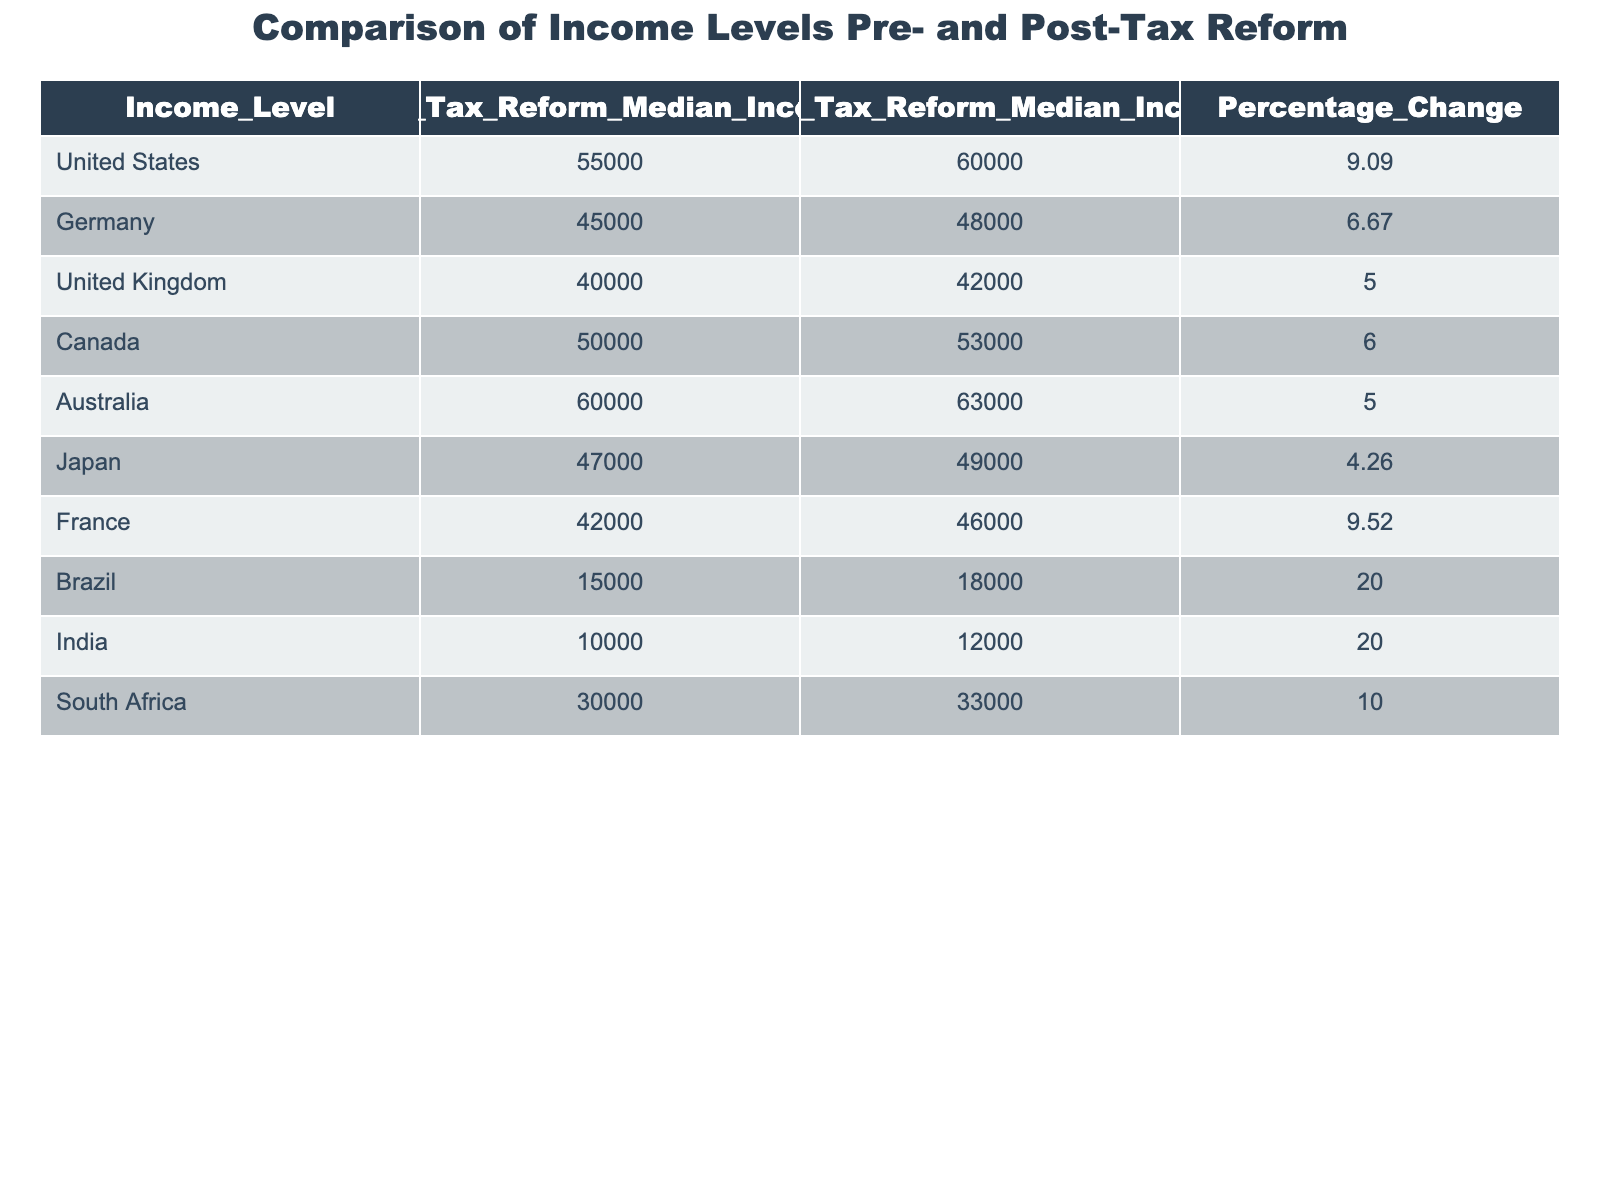What is the median income for Canada before the tax reform? The table shows that the 'Pre_Tax_Reform_Median_Income' for Canada is listed as 50000.
Answer: 50000 Which country had the highest percentage change in median income after the tax reform? By examining the 'Percentage_Change' column, Brazil and India both show a percentage change of 20.00, which is the highest compared to other countries.
Answer: Brazil and India What is the median income for the United States after the tax reform? The 'Post_Tax_Reform_Median_Income' for the United States is 60000 as seen in the table.
Answer: 60000 Which country experienced a decline in income levels post-tax reform? There are no countries listed in the table with a decrease in median income after the tax reform. Thus, the answer is no.
Answer: No What is the difference in median income for Germany before and after the tax reform? The difference is calculated as the 'Post_Tax_Reform_Median_Income' (48000) minus the 'Pre_Tax_Reform_Median_Income' (45000), which equals 3000.
Answer: 3000 What is the average percentage change across all countries listed? To find the average, sum all the percentage changes and divide by the number of countries. The sum is 9.09 + 6.67 + 5.00 + 6.00 + 5.00 + 4.26 + 9.52 + 20.00 + 20.00 + 10.00 = 75.54. Dividing this by 10 gives an average of 7.554.
Answer: 7.55 Does France have a higher median income post-tax reform than Japan? Comparing the 'Post_Tax_Reform_Median_Income' values for both countries, France is 46000 and Japan is 49000. Japan has a higher value.
Answer: No What can be inferred about the overall effectiveness of the tax reform in terms of percentage change? By reviewing the 'Percentage_Change' for each country, several countries show significant increases, especially Brazil and India, suggesting the tax reform had a positive effect on income levels.
Answer: The reform was effective overall 